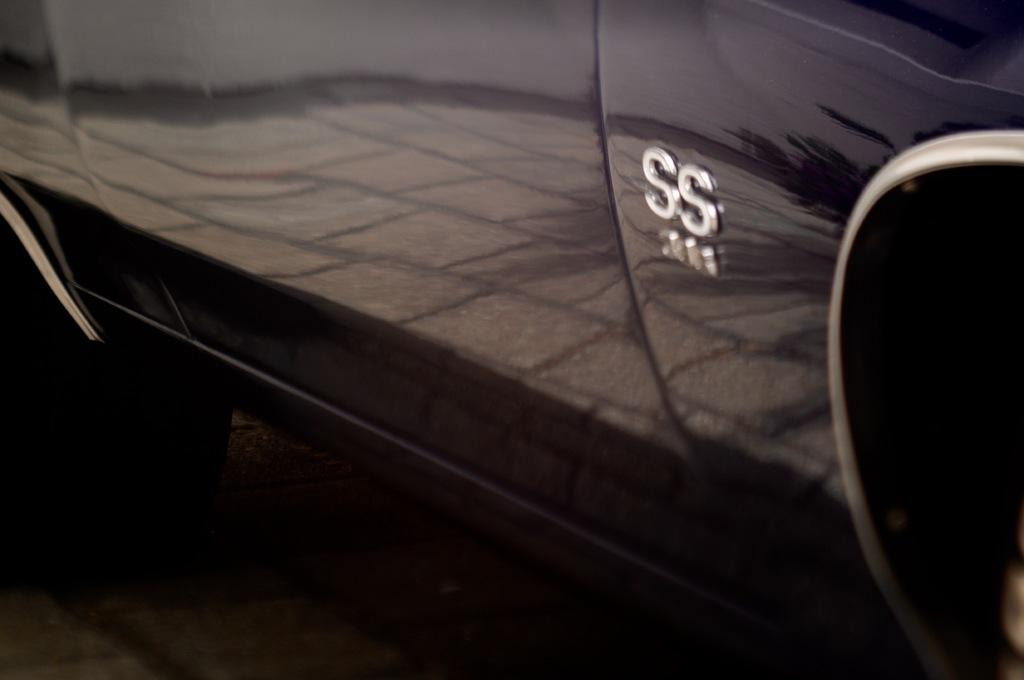What is the main subject of the image? The main subject of the image is a vehicle. Where is the vehicle located in the image? The vehicle is on the ground in the image. What feature can be seen on the vehicle? There are letter boards on the vehicle. What can be observed about the vehicle's surroundings in the image? The image shows reflections of the ground, a tree, and the sky on the vehicle. What month is depicted in the image? There is no specific month depicted in the image; it shows a vehicle with reflections of its surroundings. Can you see a playground in the image? There is no playground visible in the image; it shows a vehicle with reflections of the ground, a tree, and the sky. 